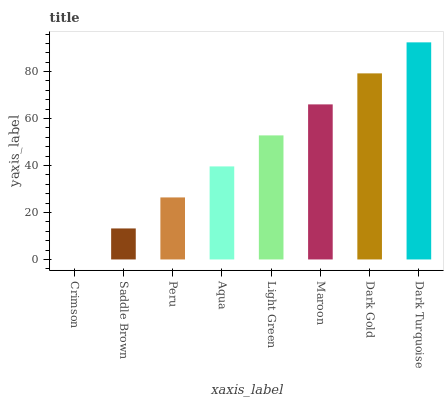Is Crimson the minimum?
Answer yes or no. Yes. Is Dark Turquoise the maximum?
Answer yes or no. Yes. Is Saddle Brown the minimum?
Answer yes or no. No. Is Saddle Brown the maximum?
Answer yes or no. No. Is Saddle Brown greater than Crimson?
Answer yes or no. Yes. Is Crimson less than Saddle Brown?
Answer yes or no. Yes. Is Crimson greater than Saddle Brown?
Answer yes or no. No. Is Saddle Brown less than Crimson?
Answer yes or no. No. Is Light Green the high median?
Answer yes or no. Yes. Is Aqua the low median?
Answer yes or no. Yes. Is Peru the high median?
Answer yes or no. No. Is Light Green the low median?
Answer yes or no. No. 